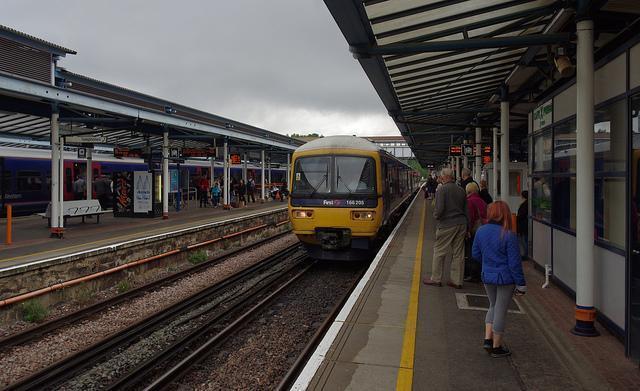At what locale do the people stand?
Make your selection from the four choices given to correctly answer the question.
Options: Forest station, train depot, market, music studios. Train depot. 